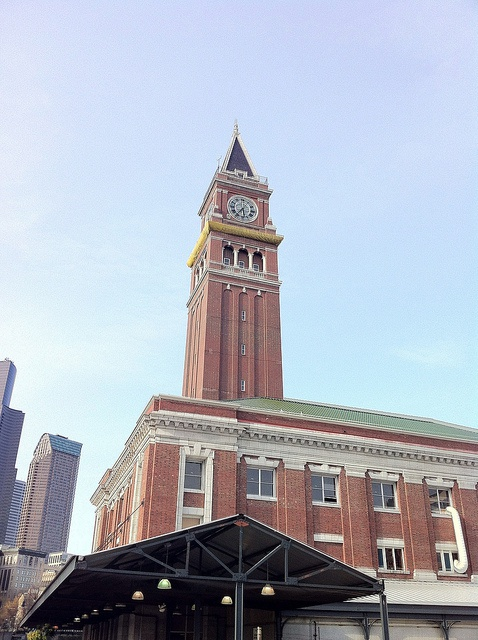Describe the objects in this image and their specific colors. I can see a clock in lavender, darkgray, gray, and lightgray tones in this image. 